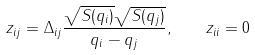Convert formula to latex. <formula><loc_0><loc_0><loc_500><loc_500>z _ { i j } = \Delta _ { i j } \frac { \sqrt { S ( q _ { i } ) } \sqrt { S ( q _ { j } ) } } { q _ { i } - q _ { j } } , \quad z _ { i i } = 0</formula> 